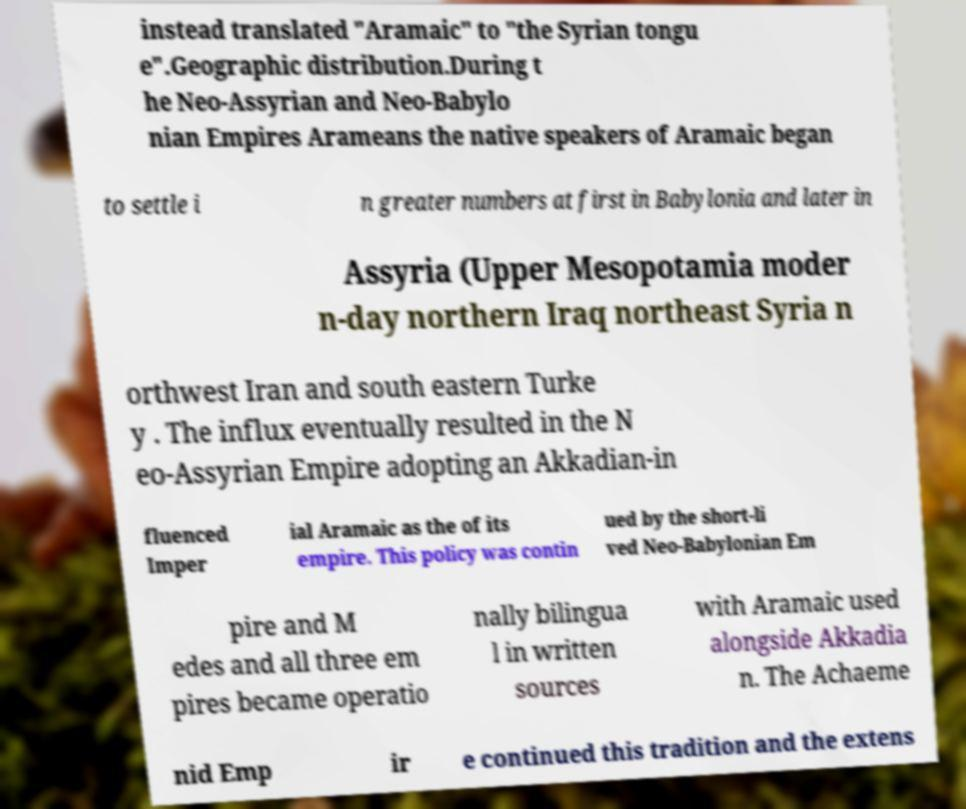Please read and relay the text visible in this image. What does it say? instead translated "Aramaic" to "the Syrian tongu e".Geographic distribution.During t he Neo-Assyrian and Neo-Babylo nian Empires Arameans the native speakers of Aramaic began to settle i n greater numbers at first in Babylonia and later in Assyria (Upper Mesopotamia moder n-day northern Iraq northeast Syria n orthwest Iran and south eastern Turke y . The influx eventually resulted in the N eo-Assyrian Empire adopting an Akkadian-in fluenced Imper ial Aramaic as the of its empire. This policy was contin ued by the short-li ved Neo-Babylonian Em pire and M edes and all three em pires became operatio nally bilingua l in written sources with Aramaic used alongside Akkadia n. The Achaeme nid Emp ir e continued this tradition and the extens 